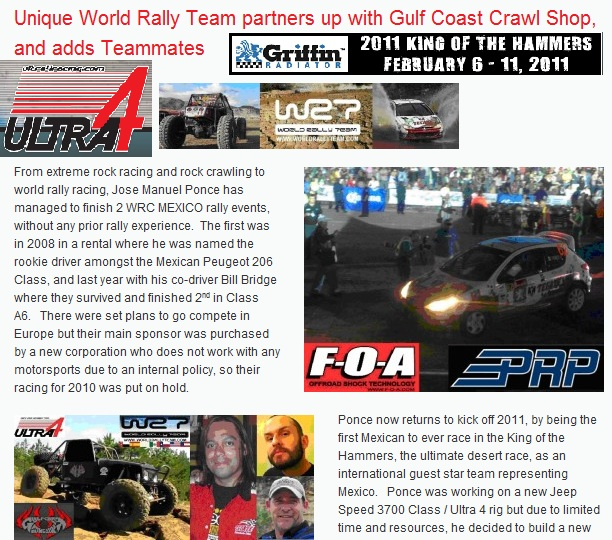Considering the various brands and logos present in the image, what can be inferred about the relationships between the individuals, teams, and companies featured? Based on the image, it can be inferred that the individuals and the Unique World Rally Team have formed partnerships or sponsorships with several brands such as 'Gulf Coast Crawl Shop', 'ULTRA4', 'F-O-A', and 'PRP'. These partnerships likely involve financial or material support provided to the rally team, as indicated by the prominent display of logos and the association of the team name with Gulf Coast Crawl Shop. The named individuals, Jose Manuel Ponce and Bill Bridge, are probably team members or drivers who are sponsored by these companies. These sponsorships enable their participation in significant rally racing events such as WRC Mexico and King of the Hammers, revealing a collaborative dynamic among the rally team and its sponsors. 